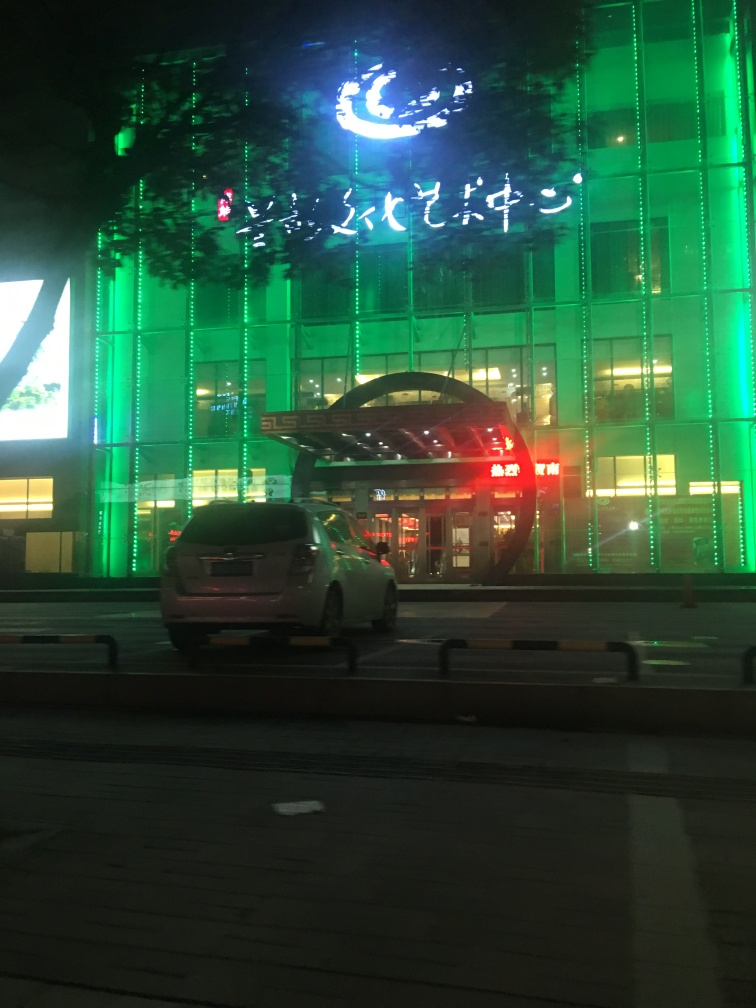Can you tell anything about the location this photo was taken at? While specific geographic information cannot be discerned, the script on the signage suggests a location that uses non-Latin writing. The modern infrastructure and lighting imply an urban setting, likely a city with contemporary amenities. Are there any notable features about the architecture or signage in the image? The building's facade is adorned with distinctive green vertical lights. The signage atop features script that is not in English and seems to glow against the nighttime backdrop, adding to the building's modern and sleek design. 